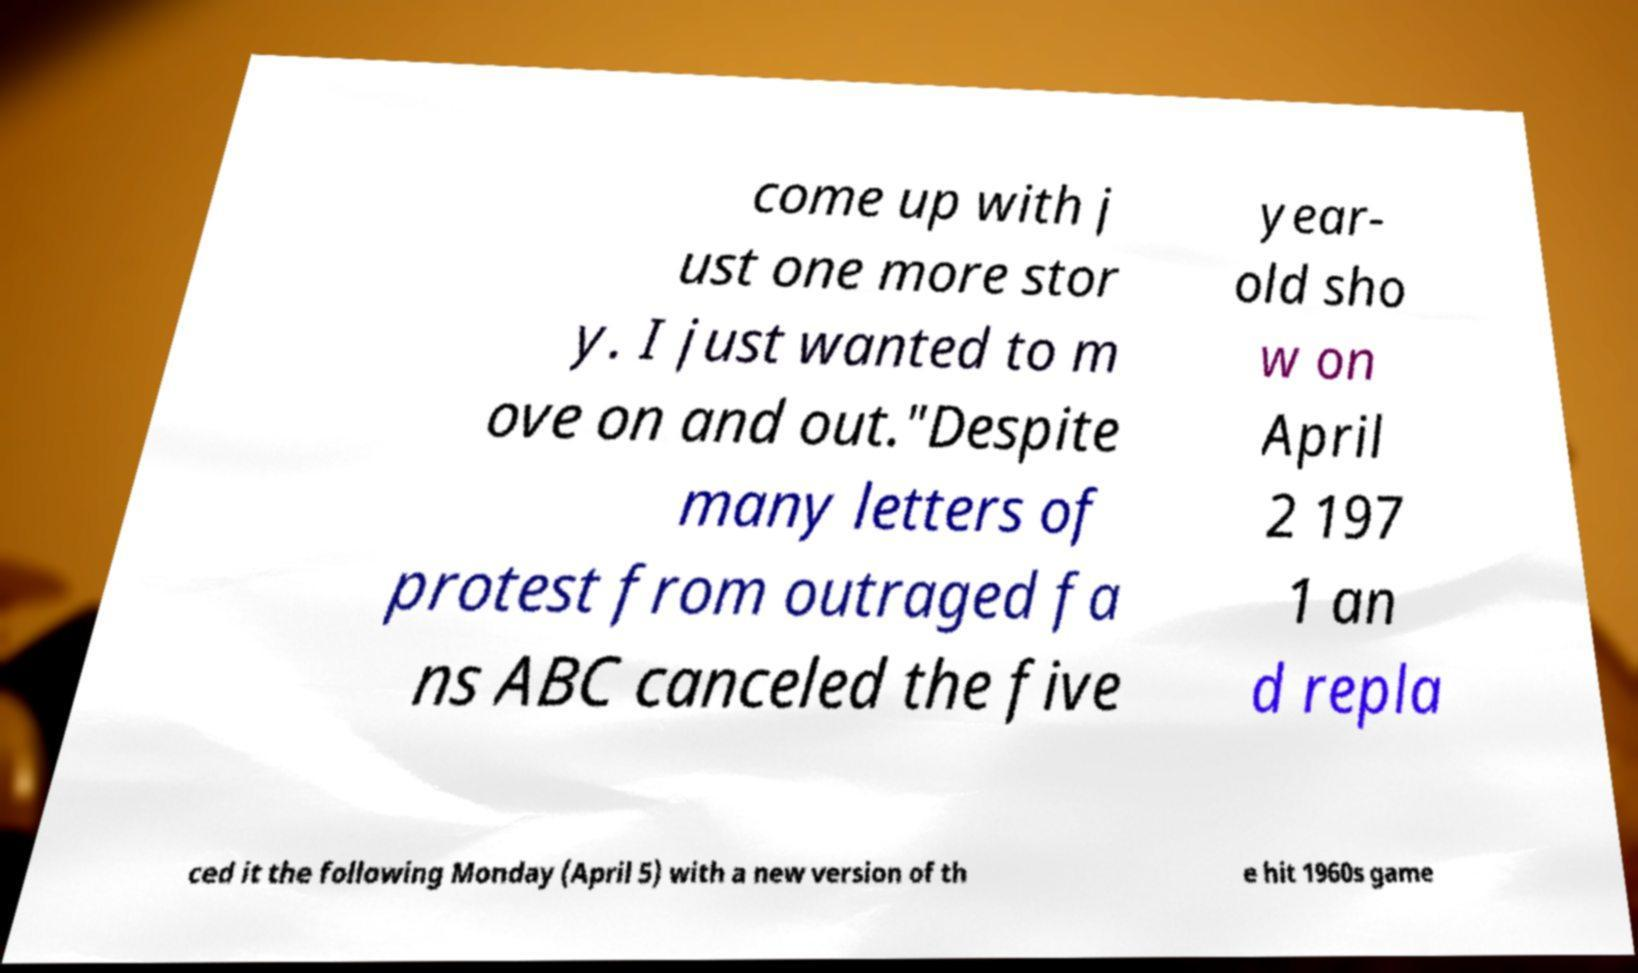What messages or text are displayed in this image? I need them in a readable, typed format. come up with j ust one more stor y. I just wanted to m ove on and out."Despite many letters of protest from outraged fa ns ABC canceled the five year- old sho w on April 2 197 1 an d repla ced it the following Monday (April 5) with a new version of th e hit 1960s game 